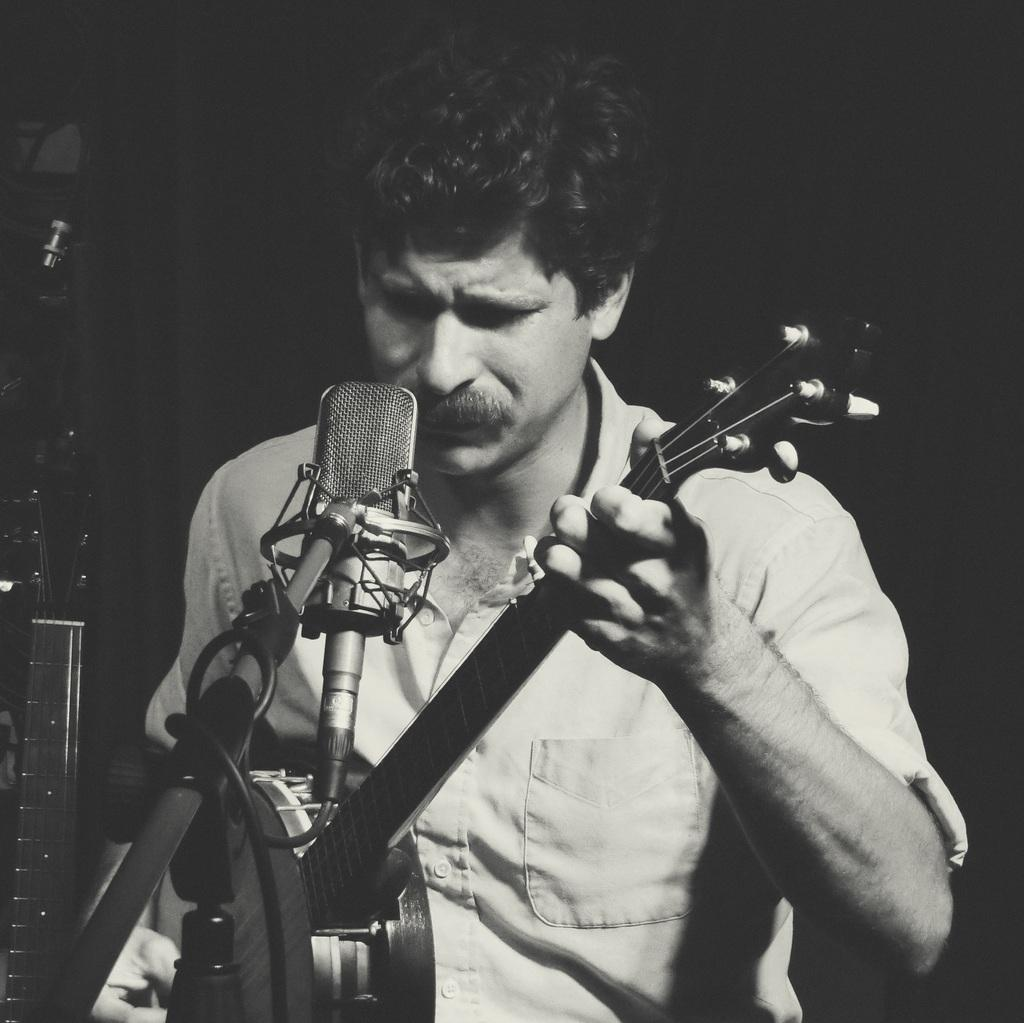What is the main subject of the image? The main subject of the image is a man. What is the man holding in the image? The man is holding a musical instrument. What can be seen on the left side of the image? There is a stand with a microphone on the left side of the image. Are there any additional elements visible in the image? Yes, there are wires visible in the image. Can you tell me how many cacti are present in the image? There are no cacti present in the image. What type of offer is the man making to the audience in the image? The image does not show the man making any offer to the audience; he is simply holding a musical instrument. 